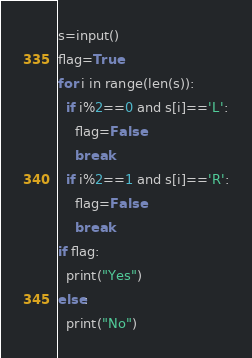<code> <loc_0><loc_0><loc_500><loc_500><_Python_>s=input()
flag=True
for i in range(len(s)):
  if i%2==0 and s[i]=='L':
    flag=False
    break
  if i%2==1 and s[i]=='R':
    flag=False
    break
if flag:
  print("Yes")
else:
  print("No")

</code> 